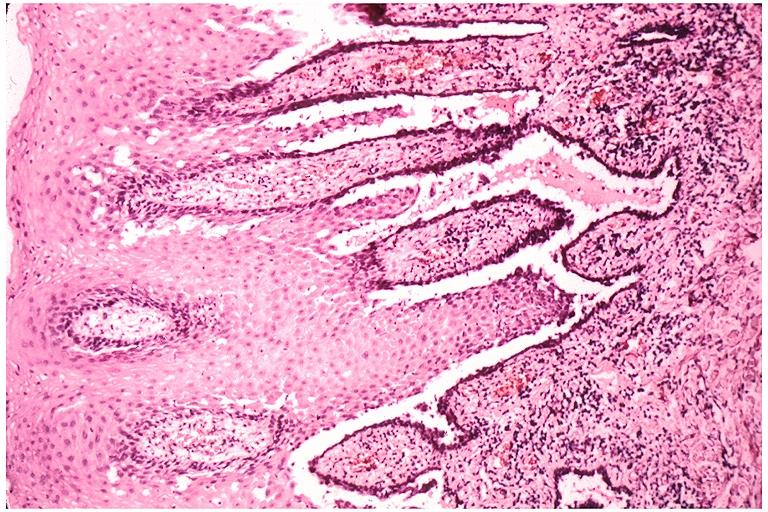does this image show pemphigus vulgaris?
Answer the question using a single word or phrase. Yes 